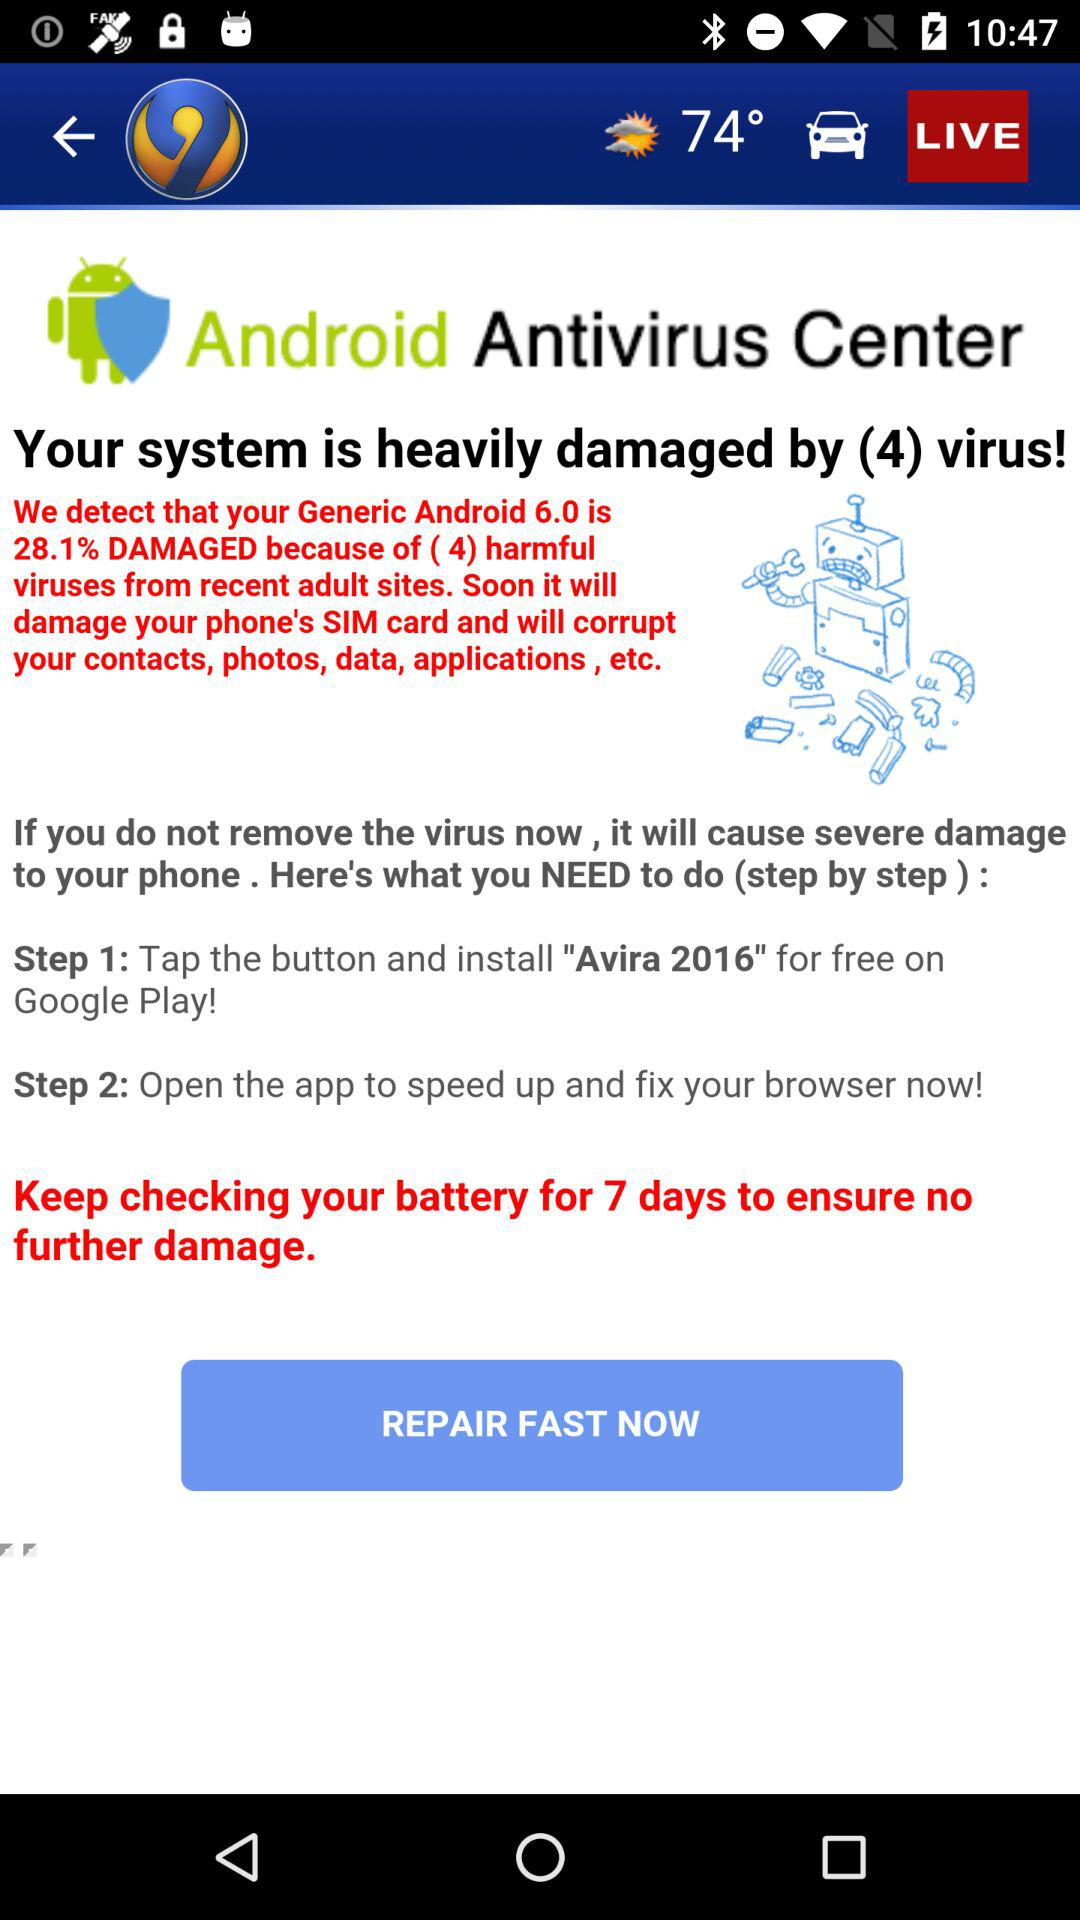How much damage is the phone at?
Answer the question using a single word or phrase. 28.1% 